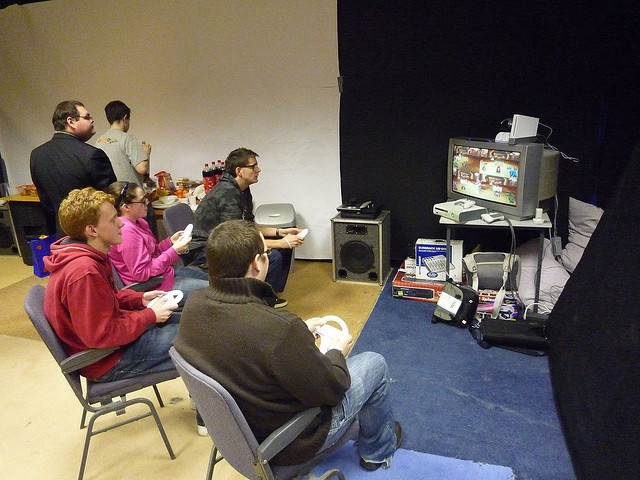Describe the objects in this image and their specific colors. I can see people in black and gray tones, people in black, brown, maroon, and salmon tones, chair in black, khaki, gray, and tan tones, tv in black, gray, and beige tones, and chair in black, gray, and darkgray tones in this image. 